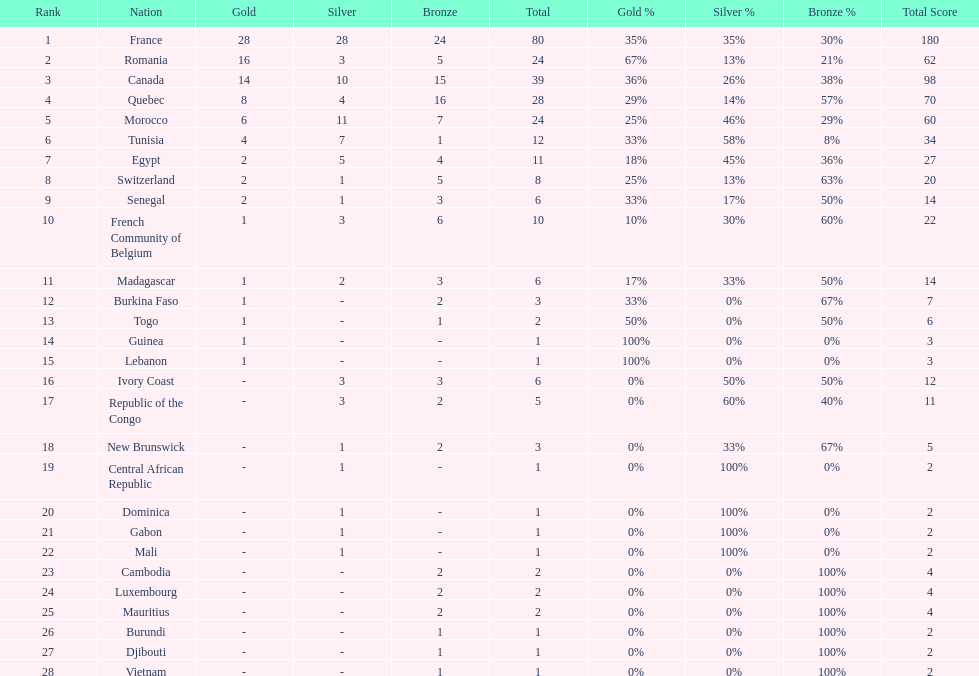What was the total medal count of switzerland? 8. 